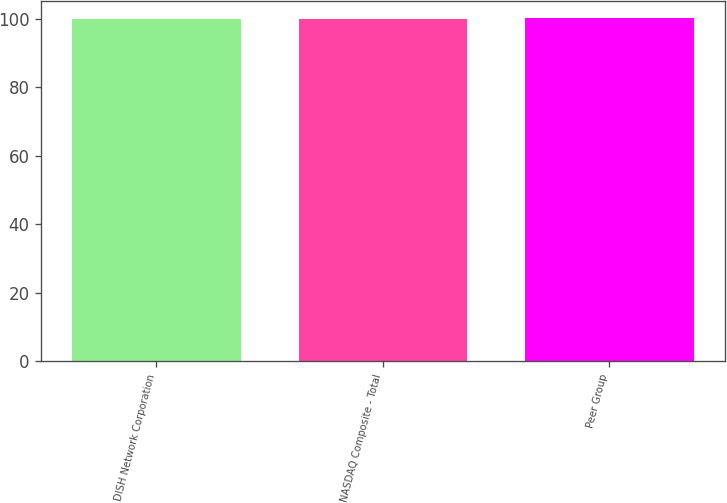Convert chart. <chart><loc_0><loc_0><loc_500><loc_500><bar_chart><fcel>DISH Network Corporation<fcel>NASDAQ Composite - Total<fcel>Peer Group<nl><fcel>100<fcel>100.1<fcel>100.2<nl></chart> 